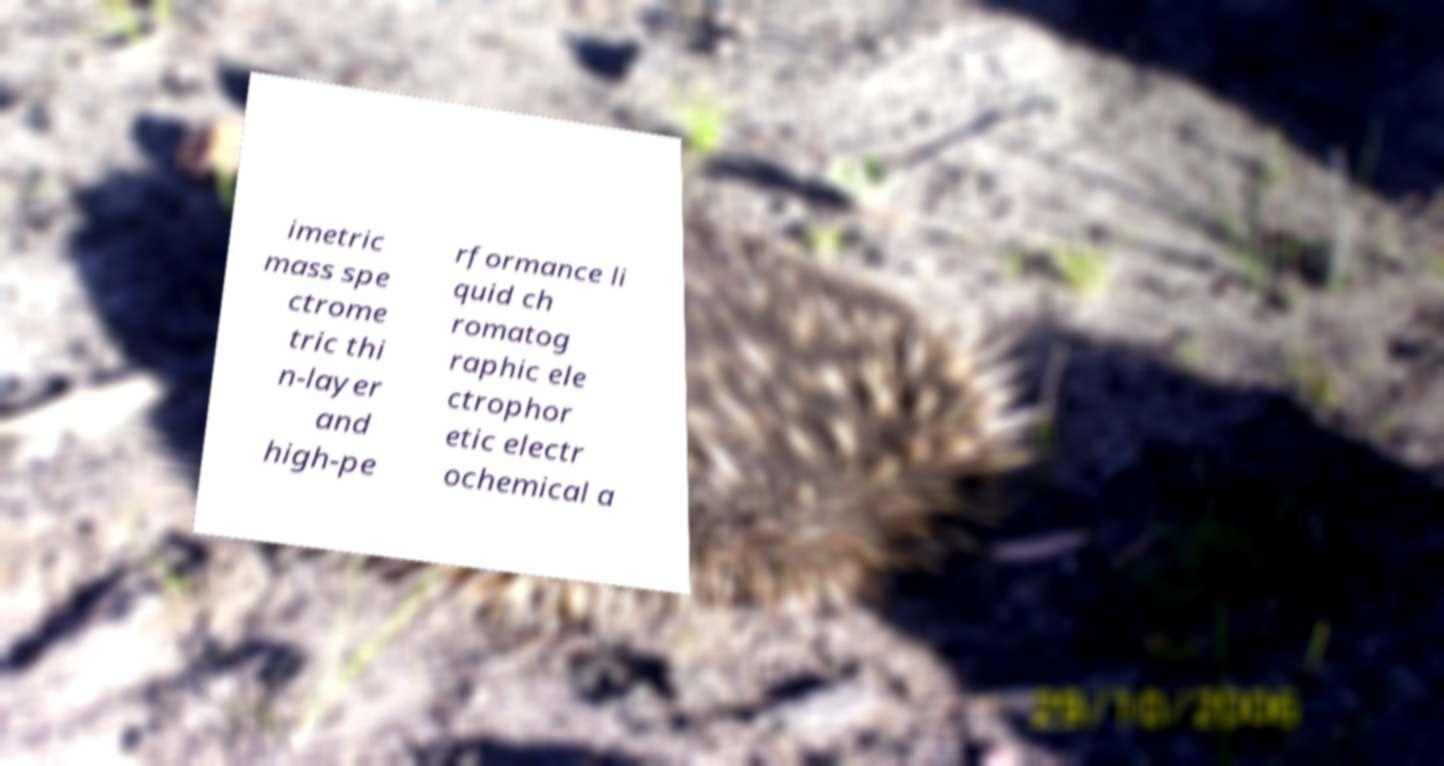Can you accurately transcribe the text from the provided image for me? imetric mass spe ctrome tric thi n-layer and high-pe rformance li quid ch romatog raphic ele ctrophor etic electr ochemical a 